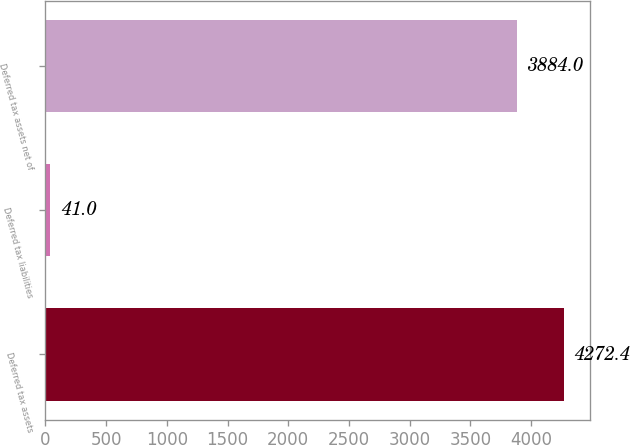Convert chart to OTSL. <chart><loc_0><loc_0><loc_500><loc_500><bar_chart><fcel>Deferred tax assets<fcel>Deferred tax liabilities<fcel>Deferred tax assets net of<nl><fcel>4272.4<fcel>41<fcel>3884<nl></chart> 